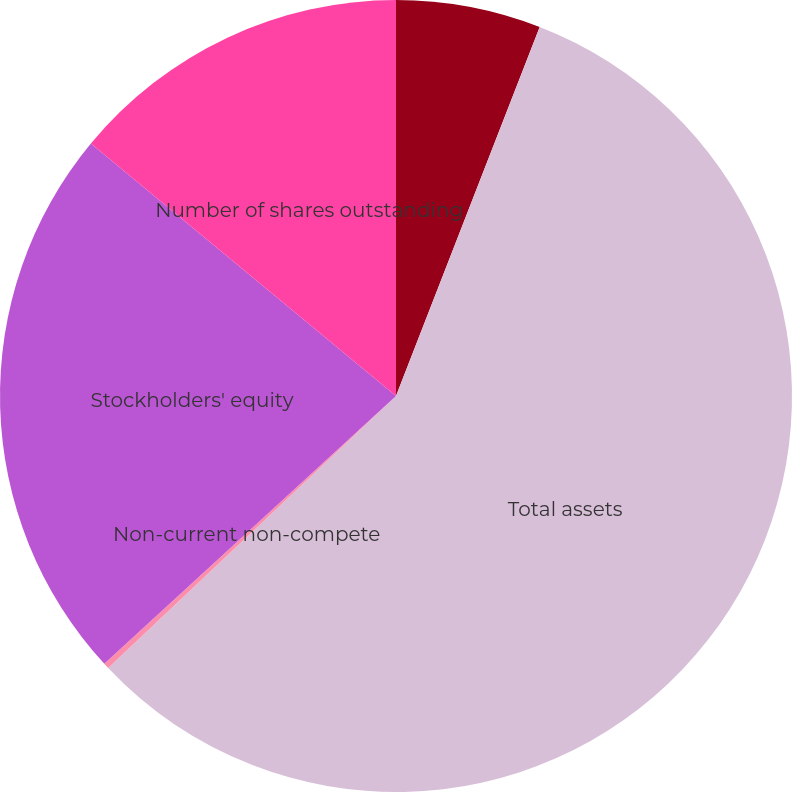Convert chart to OTSL. <chart><loc_0><loc_0><loc_500><loc_500><pie_chart><fcel>(in thousands)<fcel>Total assets<fcel>Non-current non-compete<fcel>Stockholders' equity<fcel>Number of shares outstanding<nl><fcel>5.91%<fcel>57.04%<fcel>0.23%<fcel>22.82%<fcel>14.0%<nl></chart> 